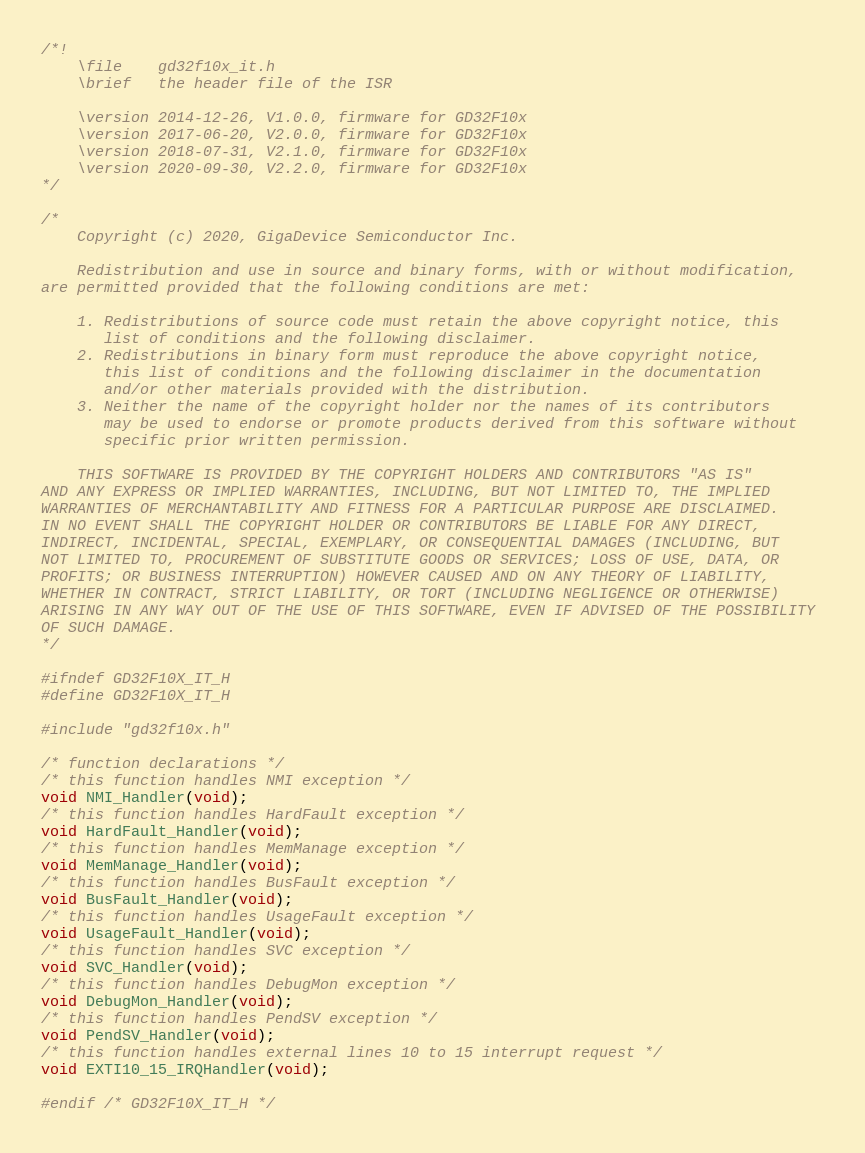Convert code to text. <code><loc_0><loc_0><loc_500><loc_500><_C_>/*!
    \file    gd32f10x_it.h
    \brief   the header file of the ISR

    \version 2014-12-26, V1.0.0, firmware for GD32F10x
    \version 2017-06-20, V2.0.0, firmware for GD32F10x
    \version 2018-07-31, V2.1.0, firmware for GD32F10x
    \version 2020-09-30, V2.2.0, firmware for GD32F10x
*/

/*
    Copyright (c) 2020, GigaDevice Semiconductor Inc.

    Redistribution and use in source and binary forms, with or without modification, 
are permitted provided that the following conditions are met:

    1. Redistributions of source code must retain the above copyright notice, this 
       list of conditions and the following disclaimer.
    2. Redistributions in binary form must reproduce the above copyright notice, 
       this list of conditions and the following disclaimer in the documentation 
       and/or other materials provided with the distribution.
    3. Neither the name of the copyright holder nor the names of its contributors 
       may be used to endorse or promote products derived from this software without 
       specific prior written permission.

    THIS SOFTWARE IS PROVIDED BY THE COPYRIGHT HOLDERS AND CONTRIBUTORS "AS IS" 
AND ANY EXPRESS OR IMPLIED WARRANTIES, INCLUDING, BUT NOT LIMITED TO, THE IMPLIED 
WARRANTIES OF MERCHANTABILITY AND FITNESS FOR A PARTICULAR PURPOSE ARE DISCLAIMED. 
IN NO EVENT SHALL THE COPYRIGHT HOLDER OR CONTRIBUTORS BE LIABLE FOR ANY DIRECT, 
INDIRECT, INCIDENTAL, SPECIAL, EXEMPLARY, OR CONSEQUENTIAL DAMAGES (INCLUDING, BUT 
NOT LIMITED TO, PROCUREMENT OF SUBSTITUTE GOODS OR SERVICES; LOSS OF USE, DATA, OR 
PROFITS; OR BUSINESS INTERRUPTION) HOWEVER CAUSED AND ON ANY THEORY OF LIABILITY, 
WHETHER IN CONTRACT, STRICT LIABILITY, OR TORT (INCLUDING NEGLIGENCE OR OTHERWISE) 
ARISING IN ANY WAY OUT OF THE USE OF THIS SOFTWARE, EVEN IF ADVISED OF THE POSSIBILITY 
OF SUCH DAMAGE.
*/

#ifndef GD32F10X_IT_H
#define GD32F10X_IT_H

#include "gd32f10x.h"

/* function declarations */
/* this function handles NMI exception */
void NMI_Handler(void);
/* this function handles HardFault exception */
void HardFault_Handler(void);
/* this function handles MemManage exception */
void MemManage_Handler(void);
/* this function handles BusFault exception */
void BusFault_Handler(void);
/* this function handles UsageFault exception */
void UsageFault_Handler(void);
/* this function handles SVC exception */
void SVC_Handler(void);
/* this function handles DebugMon exception */
void DebugMon_Handler(void);
/* this function handles PendSV exception */
void PendSV_Handler(void);
/* this function handles external lines 10 to 15 interrupt request */
void EXTI10_15_IRQHandler(void);

#endif /* GD32F10X_IT_H */
</code> 